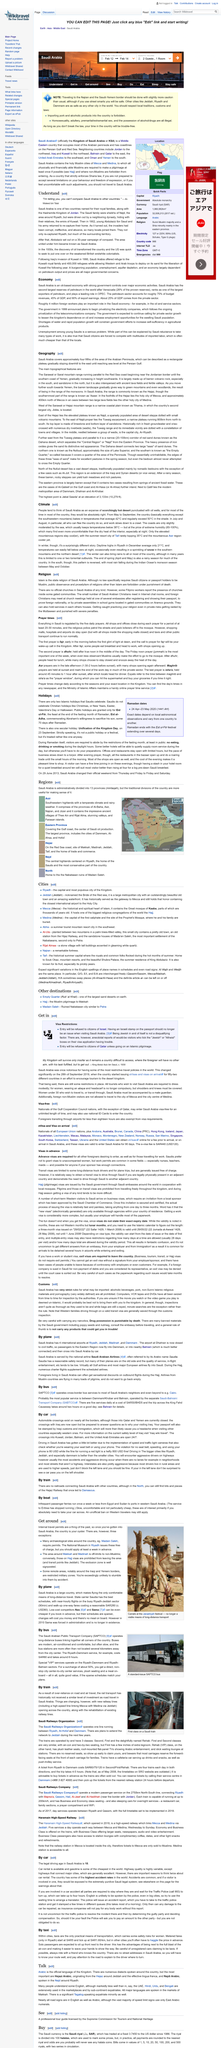Indicate a few pertinent items in this graphic. In 1999, the government privatized various companies, including electricity companies. Venezuela holds the largest reserves of petroleum in the world. The economy of Saudi Arabia is primarily built around oil, which is a vital resource that drives its economic growth and development. 